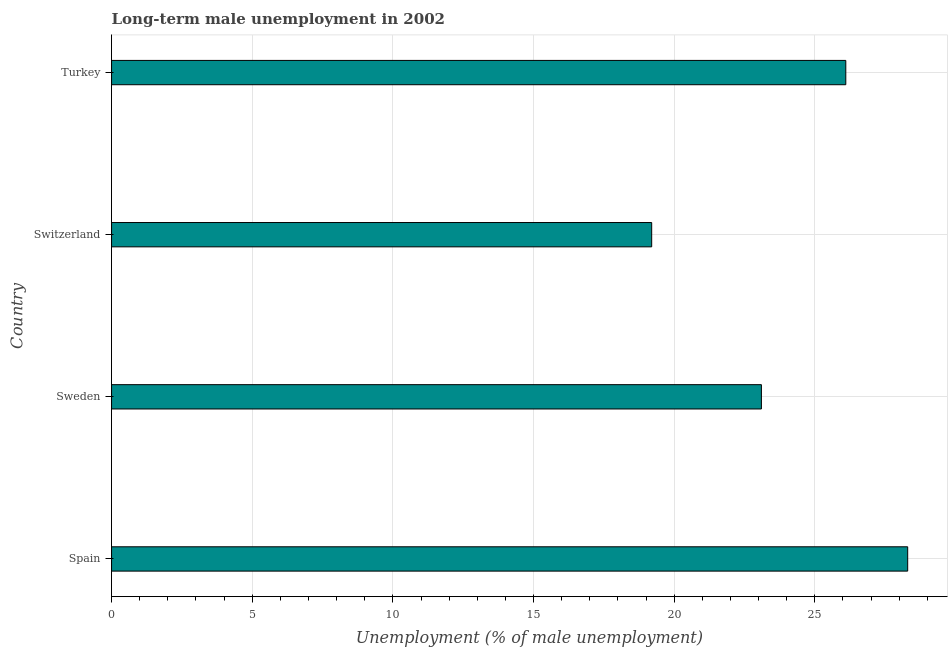What is the title of the graph?
Your answer should be compact. Long-term male unemployment in 2002. What is the label or title of the X-axis?
Give a very brief answer. Unemployment (% of male unemployment). What is the long-term male unemployment in Sweden?
Provide a short and direct response. 23.1. Across all countries, what is the maximum long-term male unemployment?
Give a very brief answer. 28.3. Across all countries, what is the minimum long-term male unemployment?
Offer a terse response. 19.2. In which country was the long-term male unemployment maximum?
Ensure brevity in your answer.  Spain. In which country was the long-term male unemployment minimum?
Keep it short and to the point. Switzerland. What is the sum of the long-term male unemployment?
Offer a terse response. 96.7. What is the difference between the long-term male unemployment in Sweden and Switzerland?
Provide a short and direct response. 3.9. What is the average long-term male unemployment per country?
Provide a short and direct response. 24.18. What is the median long-term male unemployment?
Your response must be concise. 24.6. In how many countries, is the long-term male unemployment greater than 14 %?
Your response must be concise. 4. What is the ratio of the long-term male unemployment in Spain to that in Sweden?
Offer a very short reply. 1.23. What is the difference between the highest and the second highest long-term male unemployment?
Make the answer very short. 2.2. What is the difference between the highest and the lowest long-term male unemployment?
Make the answer very short. 9.1. In how many countries, is the long-term male unemployment greater than the average long-term male unemployment taken over all countries?
Give a very brief answer. 2. How many bars are there?
Your answer should be compact. 4. Are all the bars in the graph horizontal?
Ensure brevity in your answer.  Yes. How many countries are there in the graph?
Make the answer very short. 4. Are the values on the major ticks of X-axis written in scientific E-notation?
Your response must be concise. No. What is the Unemployment (% of male unemployment) in Spain?
Offer a terse response. 28.3. What is the Unemployment (% of male unemployment) of Sweden?
Make the answer very short. 23.1. What is the Unemployment (% of male unemployment) of Switzerland?
Give a very brief answer. 19.2. What is the Unemployment (% of male unemployment) in Turkey?
Ensure brevity in your answer.  26.1. What is the difference between the Unemployment (% of male unemployment) in Sweden and Turkey?
Your answer should be very brief. -3. What is the difference between the Unemployment (% of male unemployment) in Switzerland and Turkey?
Ensure brevity in your answer.  -6.9. What is the ratio of the Unemployment (% of male unemployment) in Spain to that in Sweden?
Offer a terse response. 1.23. What is the ratio of the Unemployment (% of male unemployment) in Spain to that in Switzerland?
Your answer should be compact. 1.47. What is the ratio of the Unemployment (% of male unemployment) in Spain to that in Turkey?
Make the answer very short. 1.08. What is the ratio of the Unemployment (% of male unemployment) in Sweden to that in Switzerland?
Offer a very short reply. 1.2. What is the ratio of the Unemployment (% of male unemployment) in Sweden to that in Turkey?
Offer a terse response. 0.89. What is the ratio of the Unemployment (% of male unemployment) in Switzerland to that in Turkey?
Provide a short and direct response. 0.74. 